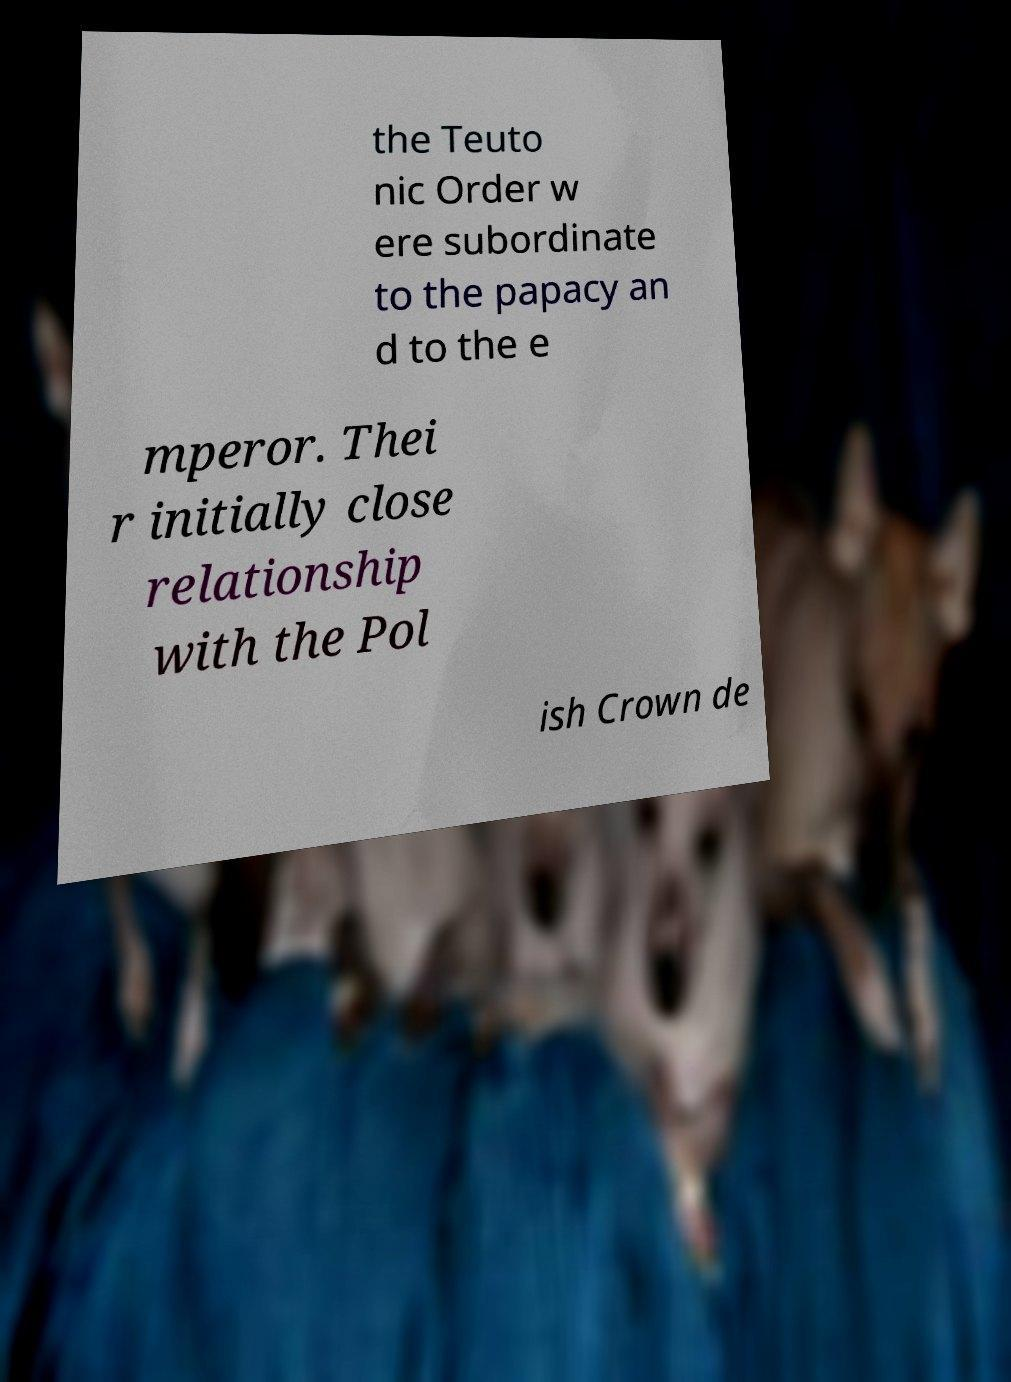Can you accurately transcribe the text from the provided image for me? the Teuto nic Order w ere subordinate to the papacy an d to the e mperor. Thei r initially close relationship with the Pol ish Crown de 